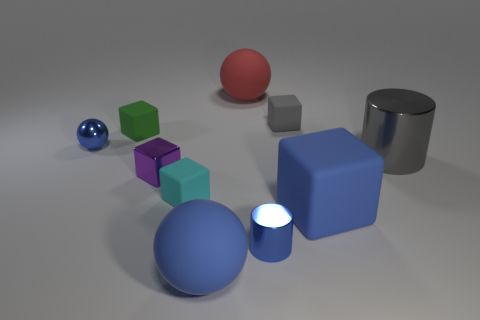There is a red thing; is its shape the same as the blue matte object that is right of the red ball?
Give a very brief answer. No. Is there anything else that is the same size as the red rubber object?
Your answer should be very brief. Yes. What is the size of the metallic thing that is the same shape as the small gray rubber thing?
Give a very brief answer. Small. Are there more big cyan blocks than gray rubber things?
Keep it short and to the point. No. Is the tiny cyan thing the same shape as the green matte object?
Provide a succinct answer. Yes. There is a big ball on the left side of the big rubber object that is behind the big gray metal cylinder; what is it made of?
Make the answer very short. Rubber. What material is the tiny object that is the same color as the shiny sphere?
Provide a succinct answer. Metal. Do the metal cube and the gray shiny thing have the same size?
Offer a terse response. No. There is a tiny blue metal thing that is on the right side of the big blue ball; are there any big blue matte things behind it?
Your response must be concise. Yes. There is a matte cube that is the same color as the tiny ball; what size is it?
Give a very brief answer. Large. 